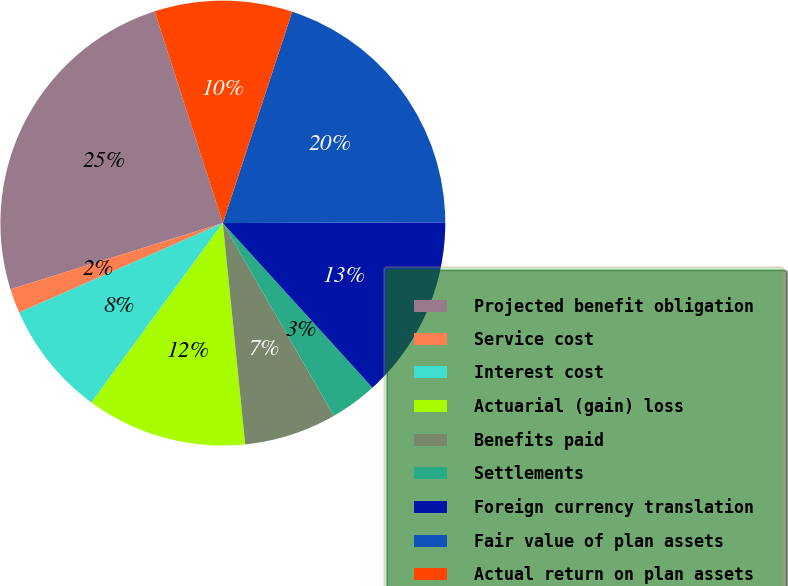Convert chart. <chart><loc_0><loc_0><loc_500><loc_500><pie_chart><fcel>Projected benefit obligation<fcel>Service cost<fcel>Interest cost<fcel>Actuarial (gain) loss<fcel>Benefits paid<fcel>Settlements<fcel>Foreign currency translation<fcel>Fair value of plan assets<fcel>Actual return on plan assets<nl><fcel>24.85%<fcel>1.77%<fcel>8.36%<fcel>11.66%<fcel>6.72%<fcel>3.42%<fcel>13.31%<fcel>19.9%<fcel>10.01%<nl></chart> 